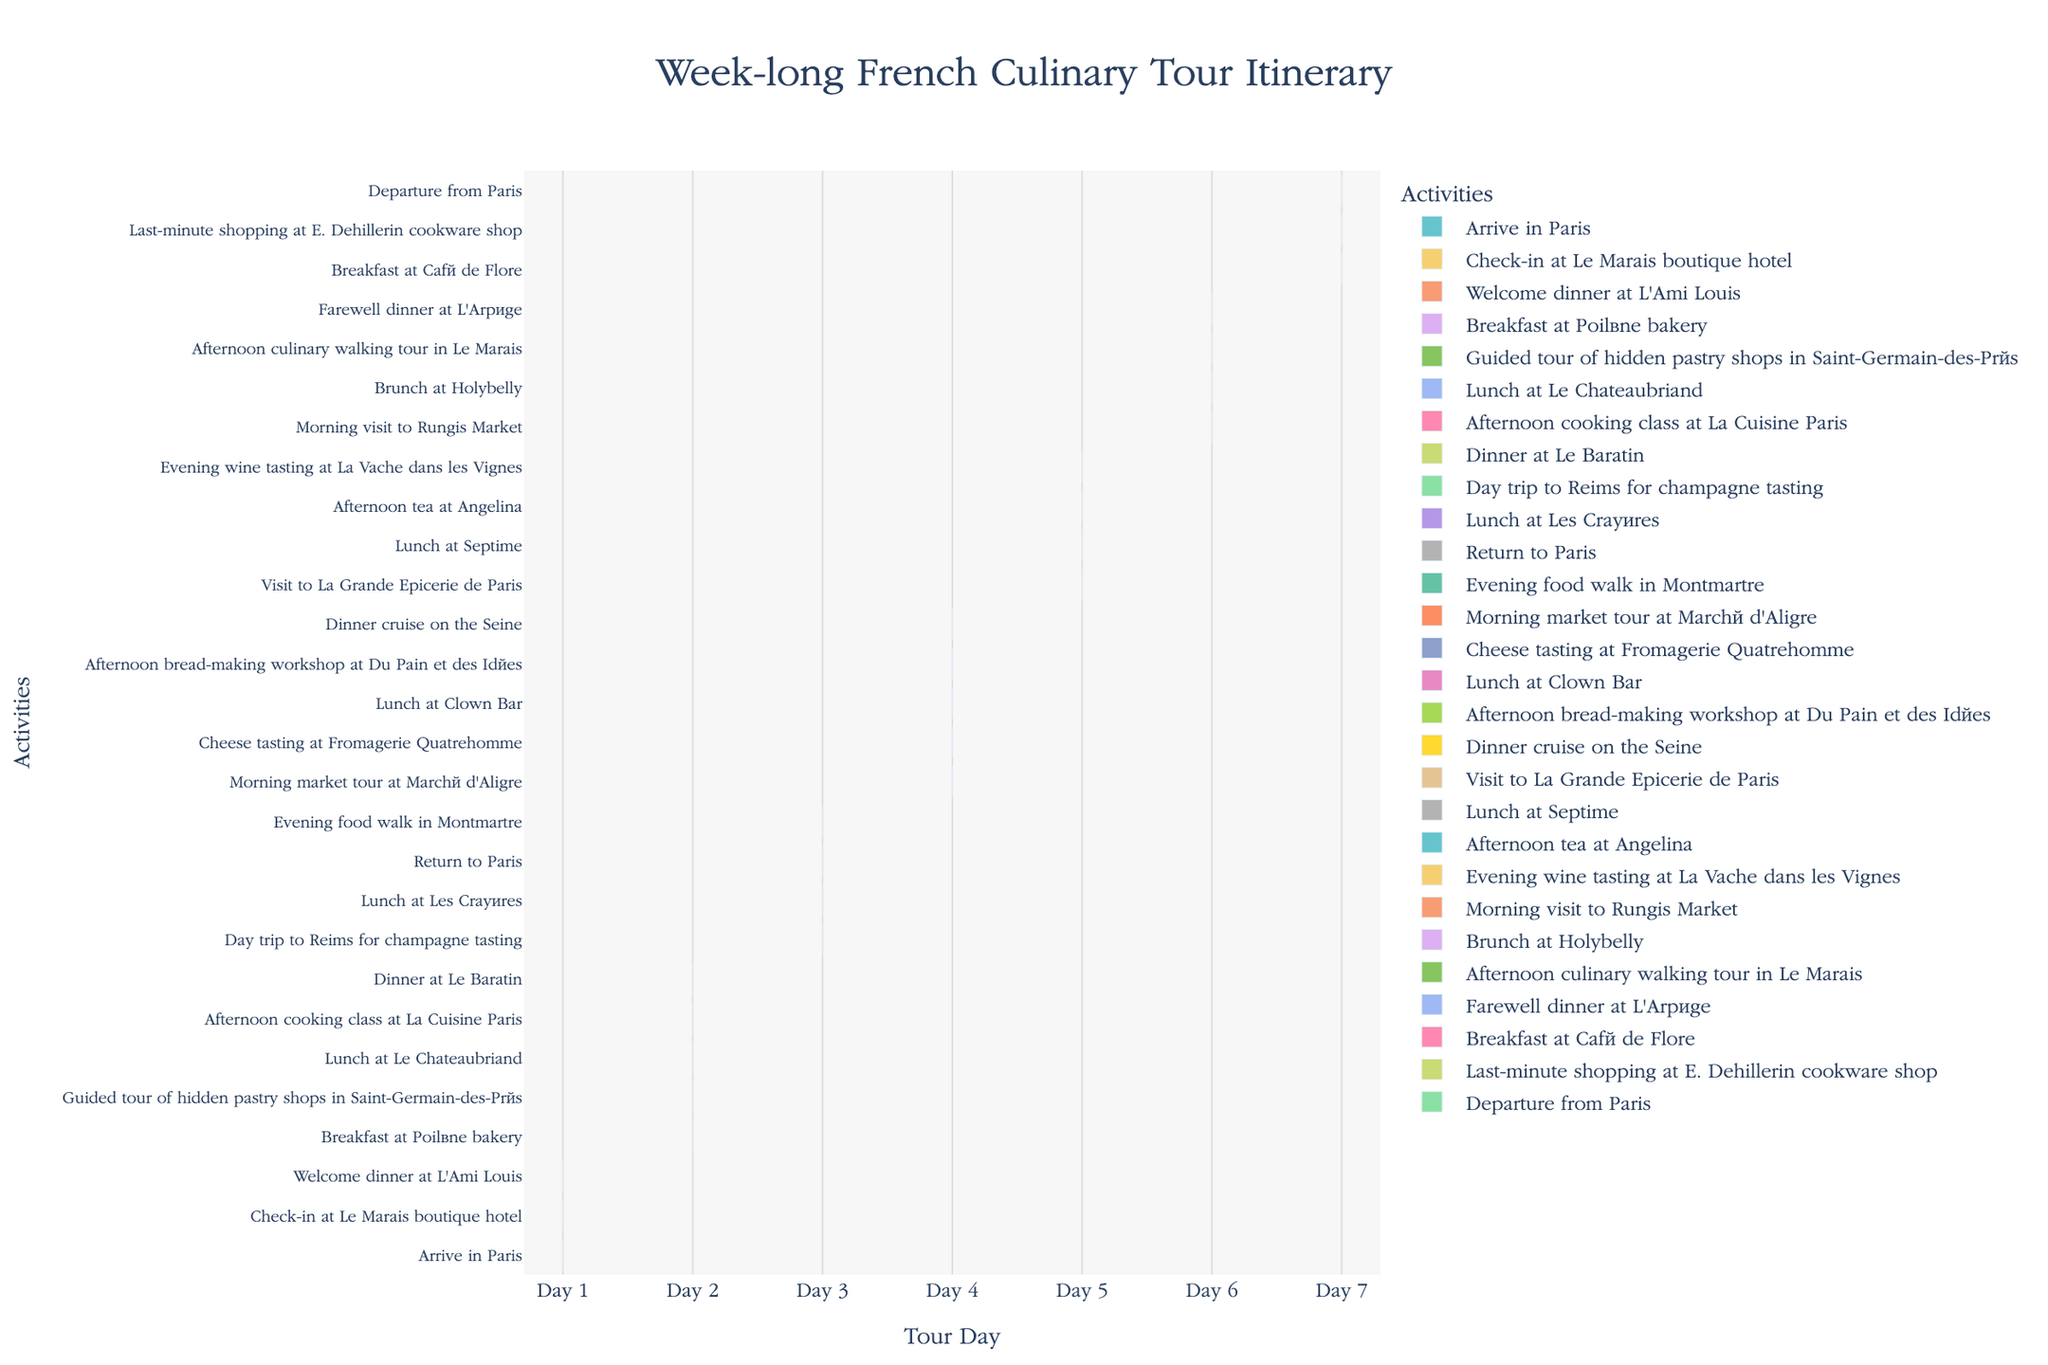What's the title of the figure? The title is usually displayed at the top of the figure. Here, it's given in the description of the plot creation.
Answer: Week-long French Culinary Tour Itinerary How many activities are planned for Day 4? To determine the number of activities for Day 4, count all tasks that start and end on Day 4.
Answer: 5 What task is scheduled immediately after "Lunch at Clown Bar"? Look for the task "Lunch at Clown Bar" and identify the next task in sequence.
Answer: Afternoon bread-making workshop at Du Pain et des Idées How many days involve both a morning and an afternoon activity? Count the days that have at least two tasks, one specified as a morning activity and one as an afternoon activity.
Answer: 5 Which day has the most activities scheduled? Identify the day with the highest number of tasks.
Answer: Day 2 What is the first activity scheduled on Day 6? Look for the earliest activity planned on Day 6.
Answer: Morning visit to Rungis Market On which day is the "Dinner cruise on the Seine" scheduled? Locate the task "Dinner cruise on the Seine" and identify the corresponding day.
Answer: Day 4 Are there any days with a single activity planned? If so, which ones? Look for any days in the chart that feature only one activity. In this case, each day has multiple activities, so find the days with only one.
Answer: None Which activity follows "Guided tour of hidden pastry shops in Saint-Germain-des-Prés" on Day 2? Identify the task listed immediately after "Guided tour of hidden pastry shops in Saint-Germain-des-Prés" on the timeline for Day 2.
Answer: Lunch at Le Chateaubriand 